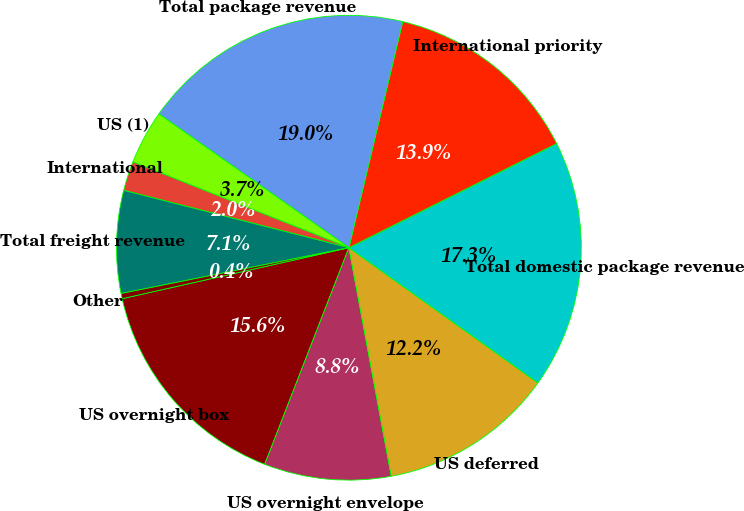Convert chart. <chart><loc_0><loc_0><loc_500><loc_500><pie_chart><fcel>US overnight box<fcel>US overnight envelope<fcel>US deferred<fcel>Total domestic package revenue<fcel>International priority<fcel>Total package revenue<fcel>US (1)<fcel>International<fcel>Total freight revenue<fcel>Other<nl><fcel>15.58%<fcel>8.82%<fcel>12.2%<fcel>17.27%<fcel>13.89%<fcel>18.96%<fcel>3.74%<fcel>2.05%<fcel>7.13%<fcel>0.36%<nl></chart> 